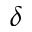Convert formula to latex. <formula><loc_0><loc_0><loc_500><loc_500>\delta</formula> 